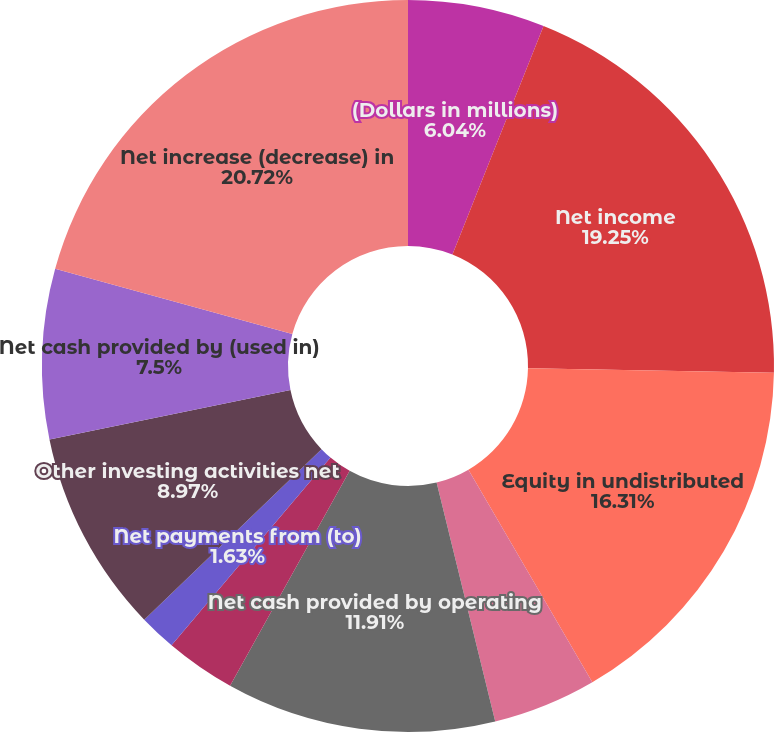Convert chart. <chart><loc_0><loc_0><loc_500><loc_500><pie_chart><fcel>(Dollars in millions)<fcel>Net income<fcel>Equity in undistributed<fcel>Other operating activities net<fcel>Net cash provided by operating<fcel>Net (purchases) sales of<fcel>Net payments from (to)<fcel>Other investing activities net<fcel>Net cash provided by (used in)<fcel>Net increase (decrease) in<nl><fcel>6.04%<fcel>19.25%<fcel>16.31%<fcel>4.57%<fcel>11.91%<fcel>3.1%<fcel>1.63%<fcel>8.97%<fcel>7.5%<fcel>20.72%<nl></chart> 